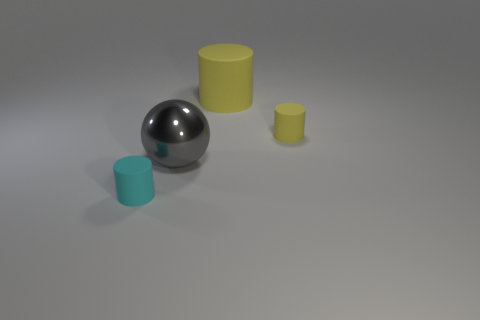Is there a cylinder?
Ensure brevity in your answer.  Yes. There is a tiny matte cylinder right of the large object on the right side of the large metal sphere; what color is it?
Make the answer very short. Yellow. How many other things are there of the same color as the large ball?
Your answer should be compact. 0. What number of objects are either big brown metallic objects or things that are right of the cyan cylinder?
Provide a short and direct response. 3. What is the color of the big thing to the right of the big gray shiny object?
Keep it short and to the point. Yellow. The big gray metallic thing has what shape?
Ensure brevity in your answer.  Sphere. What material is the small cylinder behind the small cylinder that is in front of the small yellow cylinder?
Provide a succinct answer. Rubber. What number of other things are there of the same material as the tiny cyan object
Offer a terse response. 2. What material is the yellow thing that is the same size as the cyan object?
Give a very brief answer. Rubber. Are there more tiny objects that are behind the cyan rubber object than small cyan matte cylinders that are behind the big rubber thing?
Keep it short and to the point. Yes. 